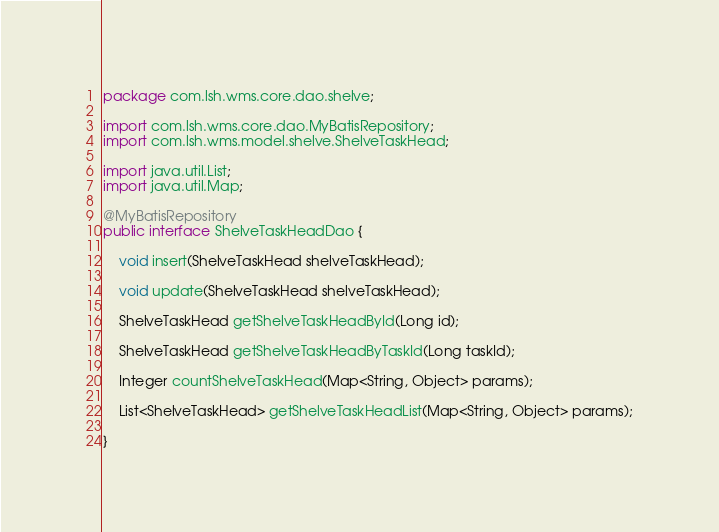Convert code to text. <code><loc_0><loc_0><loc_500><loc_500><_Java_>package com.lsh.wms.core.dao.shelve;

import com.lsh.wms.core.dao.MyBatisRepository;
import com.lsh.wms.model.shelve.ShelveTaskHead;

import java.util.List;
import java.util.Map;

@MyBatisRepository
public interface ShelveTaskHeadDao {

	void insert(ShelveTaskHead shelveTaskHead);
	
	void update(ShelveTaskHead shelveTaskHead);
	
	ShelveTaskHead getShelveTaskHeadById(Long id);

	ShelveTaskHead getShelveTaskHeadByTaskId(Long taskId);

    Integer countShelveTaskHead(Map<String, Object> params);

    List<ShelveTaskHead> getShelveTaskHeadList(Map<String, Object> params);
	
}</code> 